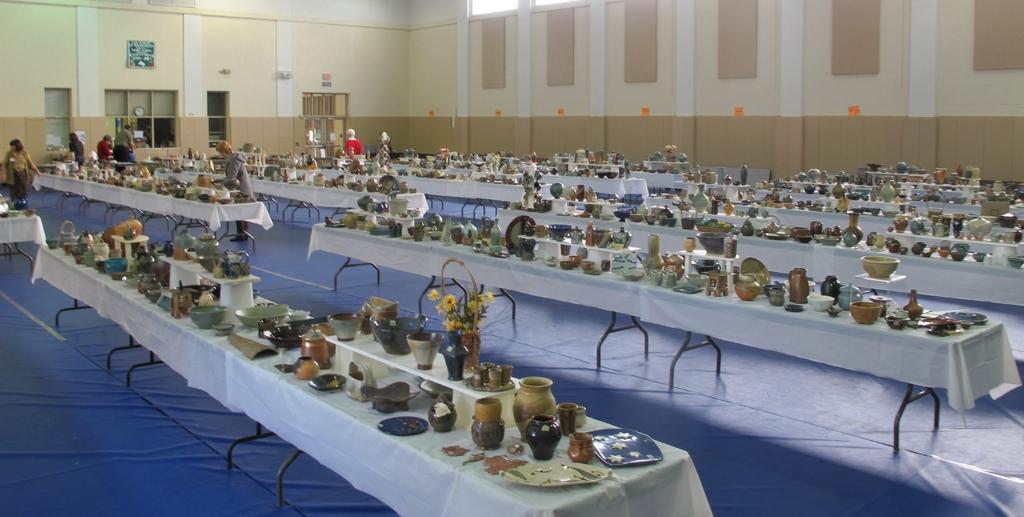In one or two sentences, can you explain what this image depicts? In this picture we can see huge hall with many tables on which old crockery and flower pots are placed. Behind we can see some women's are arranging the crockery. In the background we can see brown and cream wall with some shelves. 